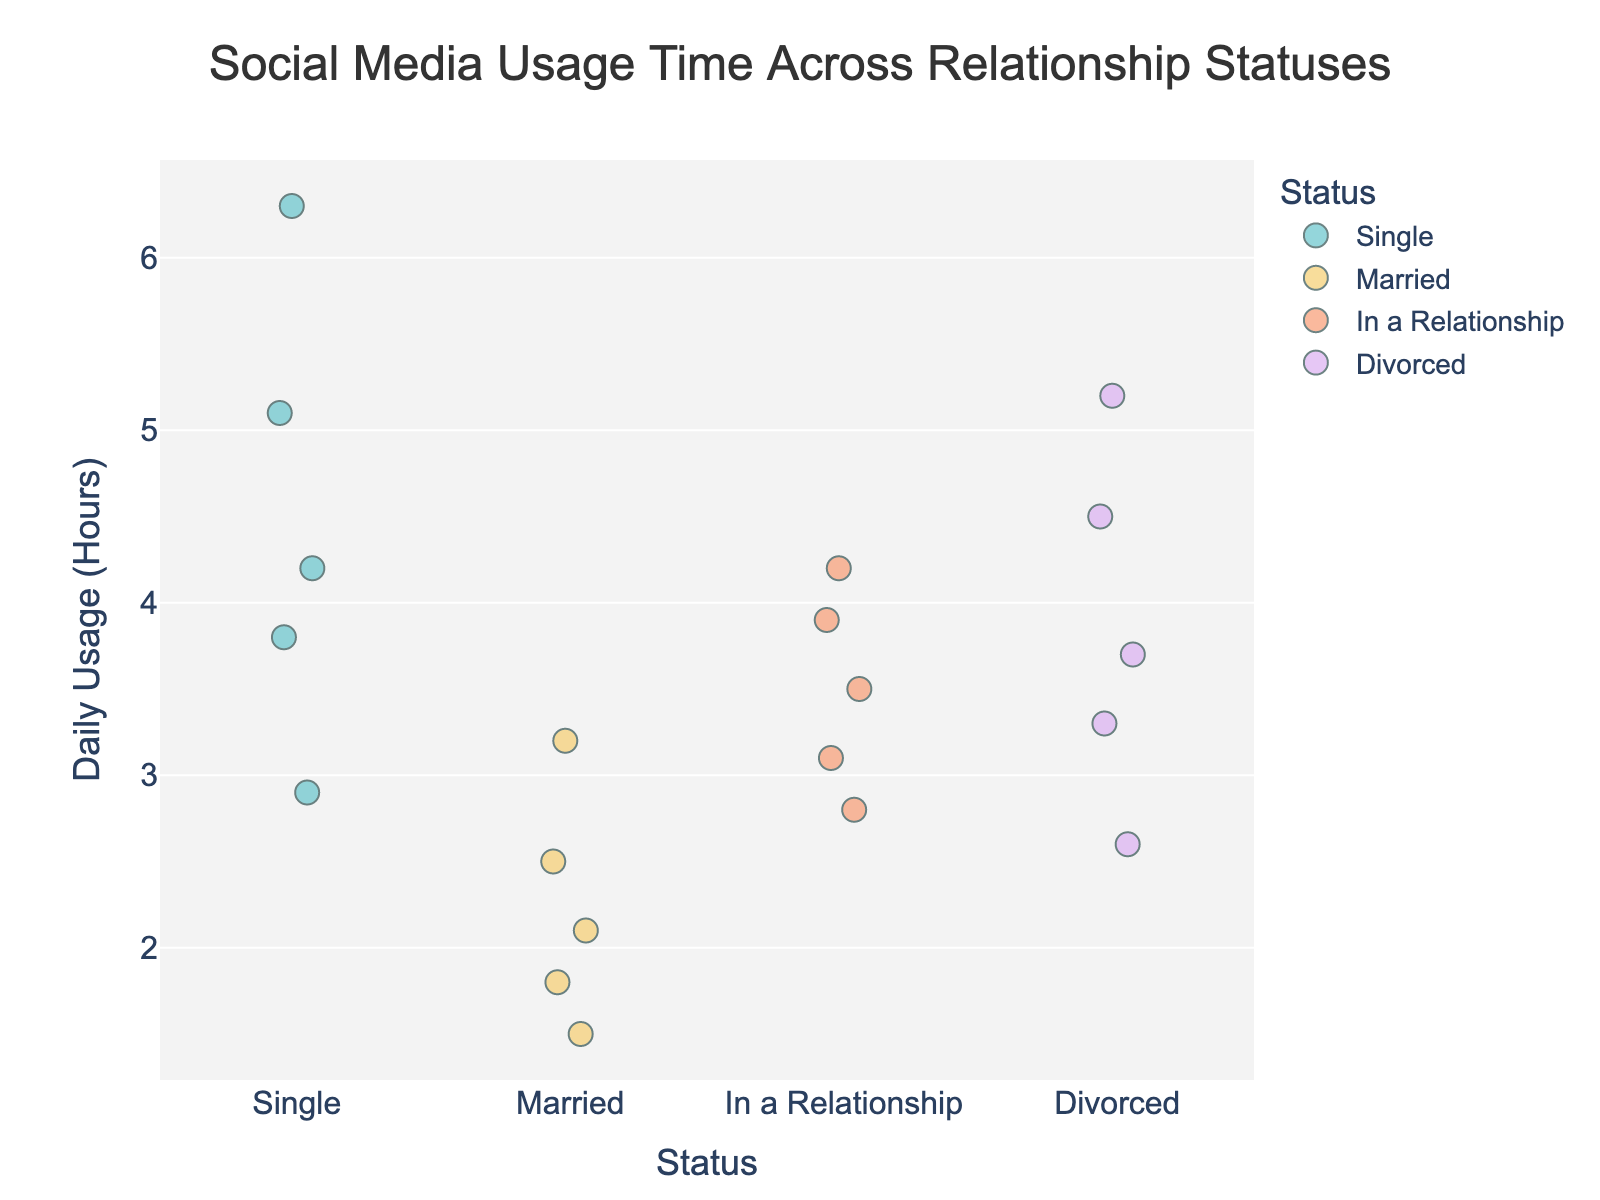What is the title of the figure? The title appears at the top of the figure, reading it provides the necessary information.
Answer: Social Media Usage Time Across Relationship Statuses How many relationship status categories are shown? By counting the distinct categories (x-axis labels) in the plot, you identify the number.
Answer: 4 Which relationship status has the highest maximum daily usage? Look at the y-axis to find the highest data point for each category. The category with the highest point indicates the maximum usage.
Answer: Single What is the range of daily usage hours for people who are married? Identify the highest and lowest points in the "Married" category on the y-axis and subtract the lowest value from the highest value.
Answer: 1.5 to 3.2 How does the average daily social media usage for singles compare to those who are divorced? Estimate the central tendency of points in both categories and compare. Single appears higher on average compared to Divorced.
Answer: Singles use more on average than Divorced Which relationship status shows the most variation in social media usage hours? Look for the category with the widest spread of points from top to bottom indicating high variation.
Answer: Single What can you infer about the social media usage of people 'In a Relationship' compared to 'Married'? Compare the clustering of data points in both categories to see patterns. People 'In a Relationship' show higher usage and more spread compared to 'Married'.
Answer: In a Relationship users have higher and more varied usage Are there any outlier data points in the category 'Single'? Check if any points are far removed from the cluster within the 'Single' category indicating outliers.
Answer: Yes, there is a point at 6.3 hours Which category has the least social media usage on average? Estimate the central tendency for each category and compare. 'Married' appears to have the lowest average usage based on data clustering.
Answer: Married 